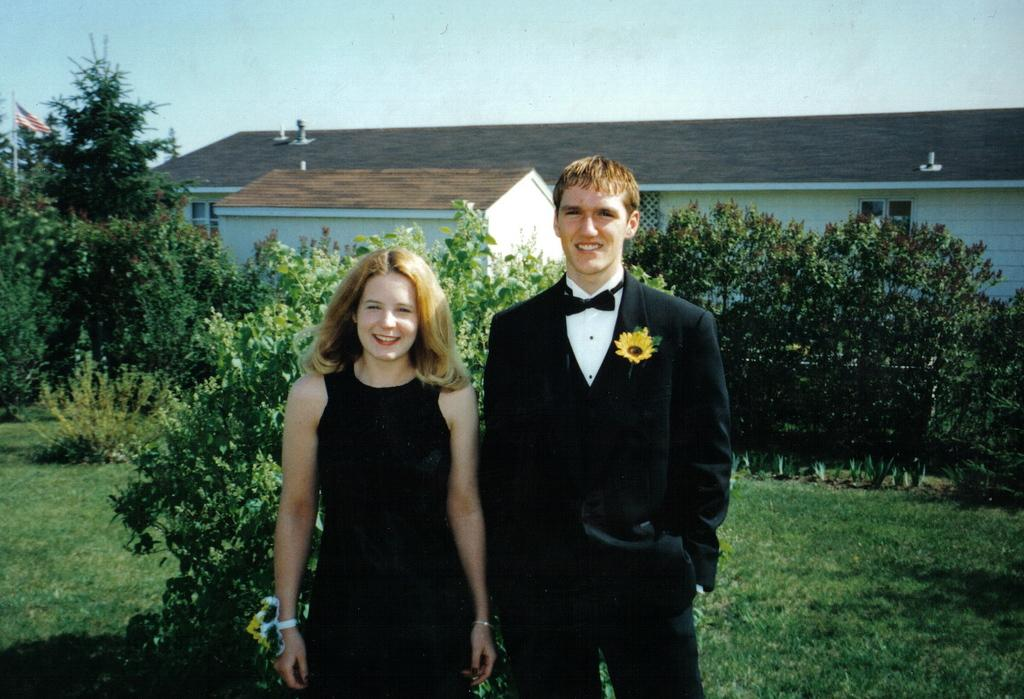How many people are in the image? There are two persons in the image. What are the people wearing? Both persons are wearing black dresses. What can be seen in the background of the image? There are plants and a house in the background of the image. What type of trains can be seen passing by in the image? There are no trains present in the image. What scientific theory is being discussed by the people in the image? There is no indication of a scientific discussion or theory in the image. 